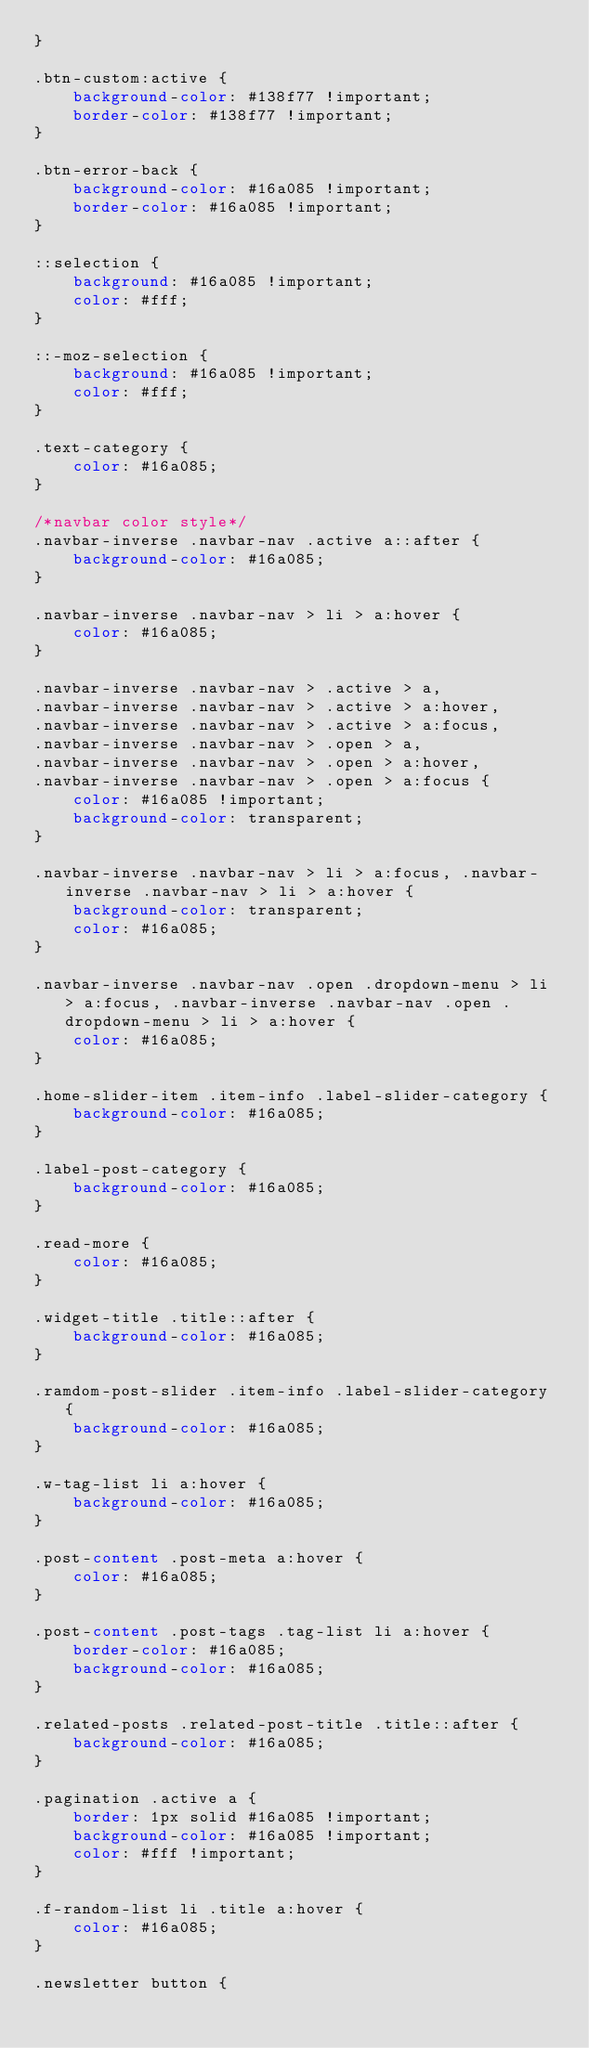Convert code to text. <code><loc_0><loc_0><loc_500><loc_500><_CSS_>}

.btn-custom:active {
	background-color: #138f77 !important;
	border-color: #138f77 !important;
}

.btn-error-back {
	background-color: #16a085 !important;
	border-color: #16a085 !important;
}

::selection {
	background: #16a085 !important;
	color: #fff;
}

::-moz-selection {
	background: #16a085 !important;
	color: #fff;
}

.text-category {
	color: #16a085;
}

/*navbar color style*/
.navbar-inverse .navbar-nav .active a::after {
	background-color: #16a085;
}

.navbar-inverse .navbar-nav > li > a:hover {
	color: #16a085;
}

.navbar-inverse .navbar-nav > .active > a,
.navbar-inverse .navbar-nav > .active > a:hover,
.navbar-inverse .navbar-nav > .active > a:focus,
.navbar-inverse .navbar-nav > .open > a,
.navbar-inverse .navbar-nav > .open > a:hover,
.navbar-inverse .navbar-nav > .open > a:focus {
	color: #16a085 !important;
	background-color: transparent;
}

.navbar-inverse .navbar-nav > li > a:focus, .navbar-inverse .navbar-nav > li > a:hover {
	background-color: transparent;
	color: #16a085;
}

.navbar-inverse .navbar-nav .open .dropdown-menu > li > a:focus, .navbar-inverse .navbar-nav .open .dropdown-menu > li > a:hover {
	color: #16a085;
}

.home-slider-item .item-info .label-slider-category {
	background-color: #16a085;
}

.label-post-category {
	background-color: #16a085;
}

.read-more {
	color: #16a085;
}

.widget-title .title::after {
	background-color: #16a085;
}

.ramdom-post-slider .item-info .label-slider-category {
	background-color: #16a085;
}

.w-tag-list li a:hover {
	background-color: #16a085;
}

.post-content .post-meta a:hover {
	color: #16a085;
}

.post-content .post-tags .tag-list li a:hover {
	border-color: #16a085;
	background-color: #16a085;
}

.related-posts .related-post-title .title::after {
	background-color: #16a085;
}

.pagination .active a {
	border: 1px solid #16a085 !important;
	background-color: #16a085 !important;
	color: #fff !important;
}

.f-random-list li .title a:hover {
	color: #16a085;
}

.newsletter button {</code> 